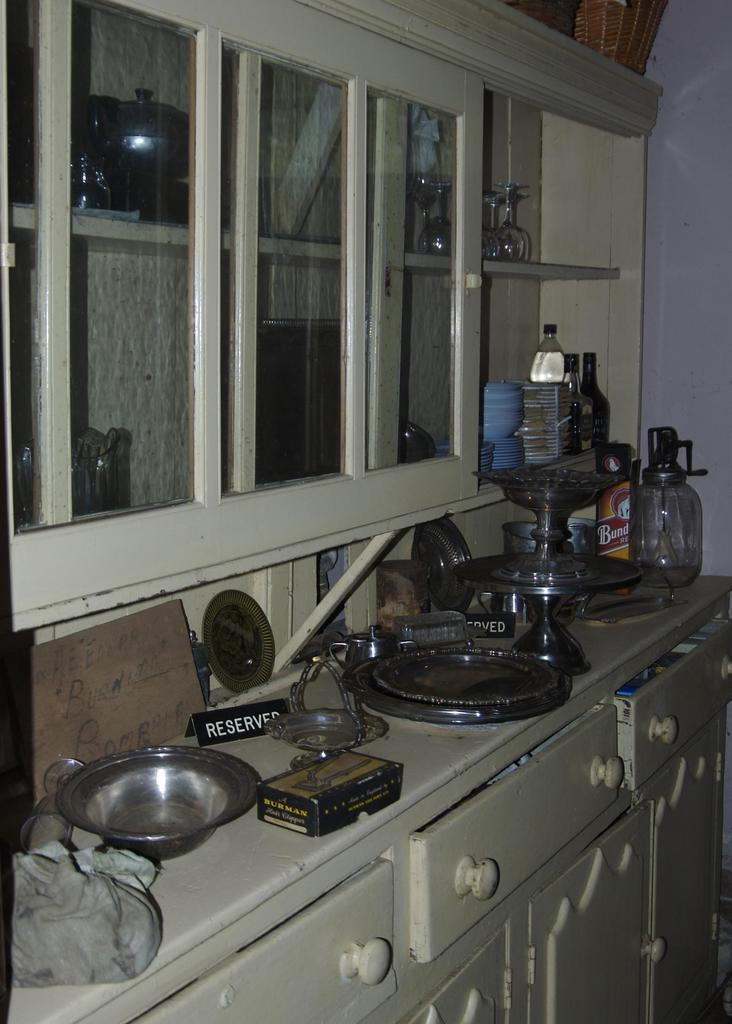<image>
Give a short and clear explanation of the subsequent image. A shelf with various items on top and a Reserved sign. 